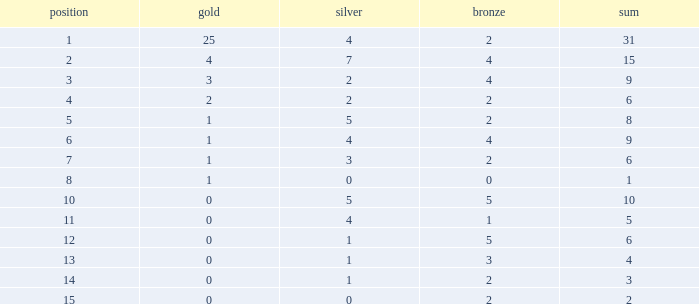What is the highest rank of the medal total less than 15, more than 2 bronzes, 0 gold and 1 silver? 13.0. 